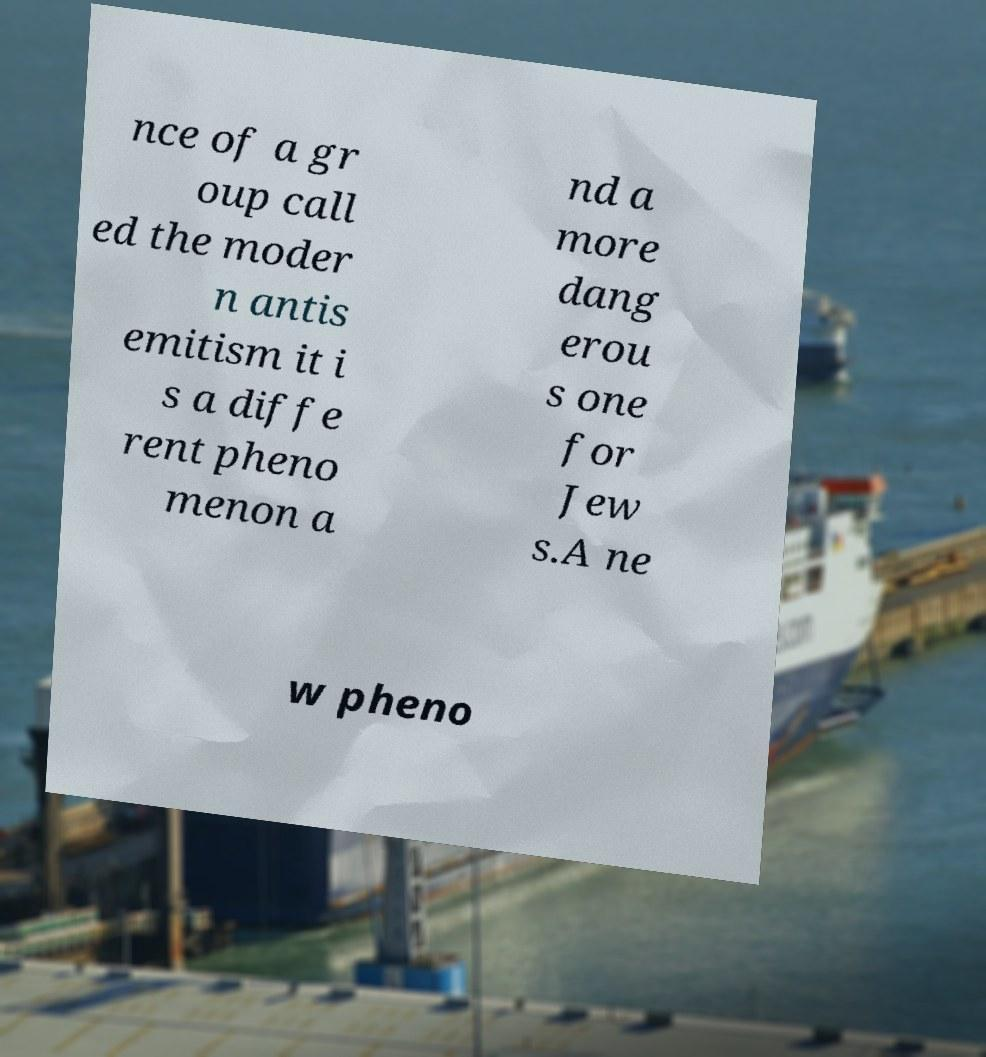I need the written content from this picture converted into text. Can you do that? nce of a gr oup call ed the moder n antis emitism it i s a diffe rent pheno menon a nd a more dang erou s one for Jew s.A ne w pheno 